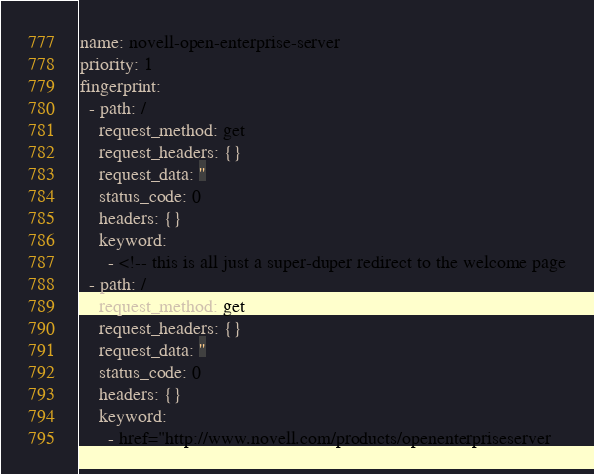<code> <loc_0><loc_0><loc_500><loc_500><_YAML_>name: novell-open-enterprise-server
priority: 1
fingerprint:
  - path: /
    request_method: get
    request_headers: {}
    request_data: ''
    status_code: 0
    headers: {}
    keyword:
      - <!-- this is all just a super-duper redirect to the welcome page
  - path: /
    request_method: get
    request_headers: {}
    request_data: ''
    status_code: 0
    headers: {}
    keyword:
      - href="http://www.novell.com/products/openenterpriseserver
</code> 